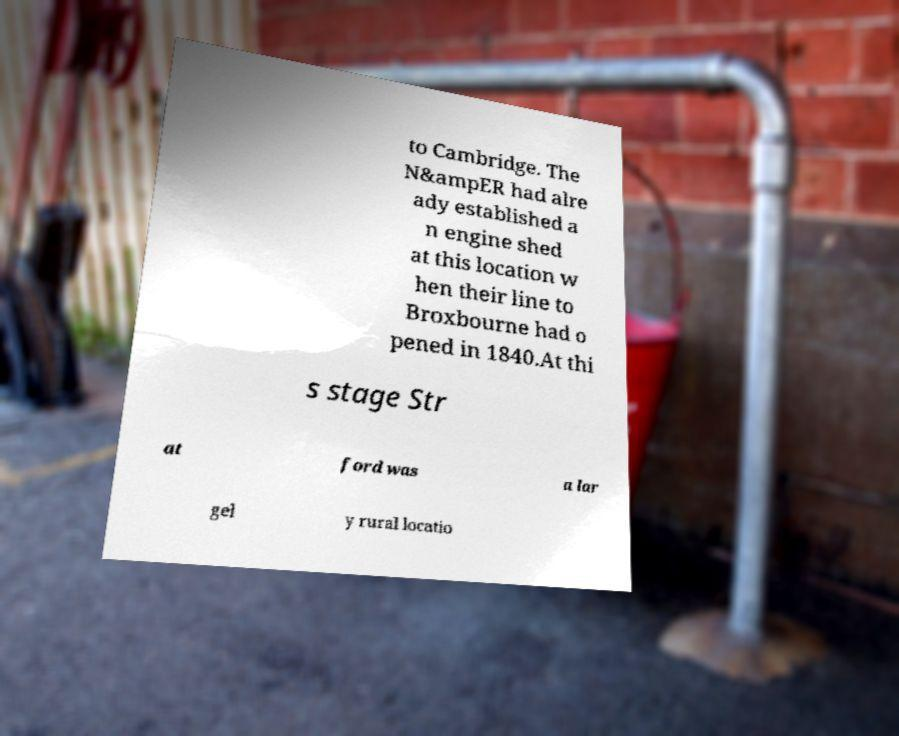There's text embedded in this image that I need extracted. Can you transcribe it verbatim? to Cambridge. The N&ampER had alre ady established a n engine shed at this location w hen their line to Broxbourne had o pened in 1840.At thi s stage Str at ford was a lar gel y rural locatio 